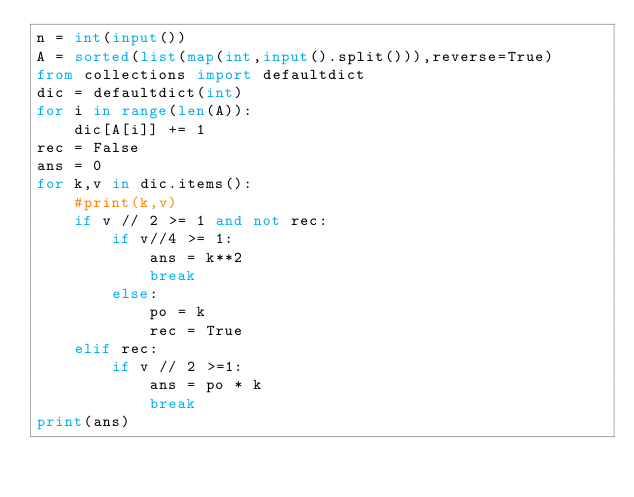<code> <loc_0><loc_0><loc_500><loc_500><_Python_>n = int(input())
A = sorted(list(map(int,input().split())),reverse=True)
from collections import defaultdict
dic = defaultdict(int)
for i in range(len(A)):
    dic[A[i]] += 1
rec = False
ans = 0
for k,v in dic.items():
    #print(k,v)
    if v // 2 >= 1 and not rec:
        if v//4 >= 1:
            ans = k**2
            break
        else:
            po = k
            rec = True
    elif rec:
        if v // 2 >=1:
            ans = po * k
            break
print(ans)
</code> 